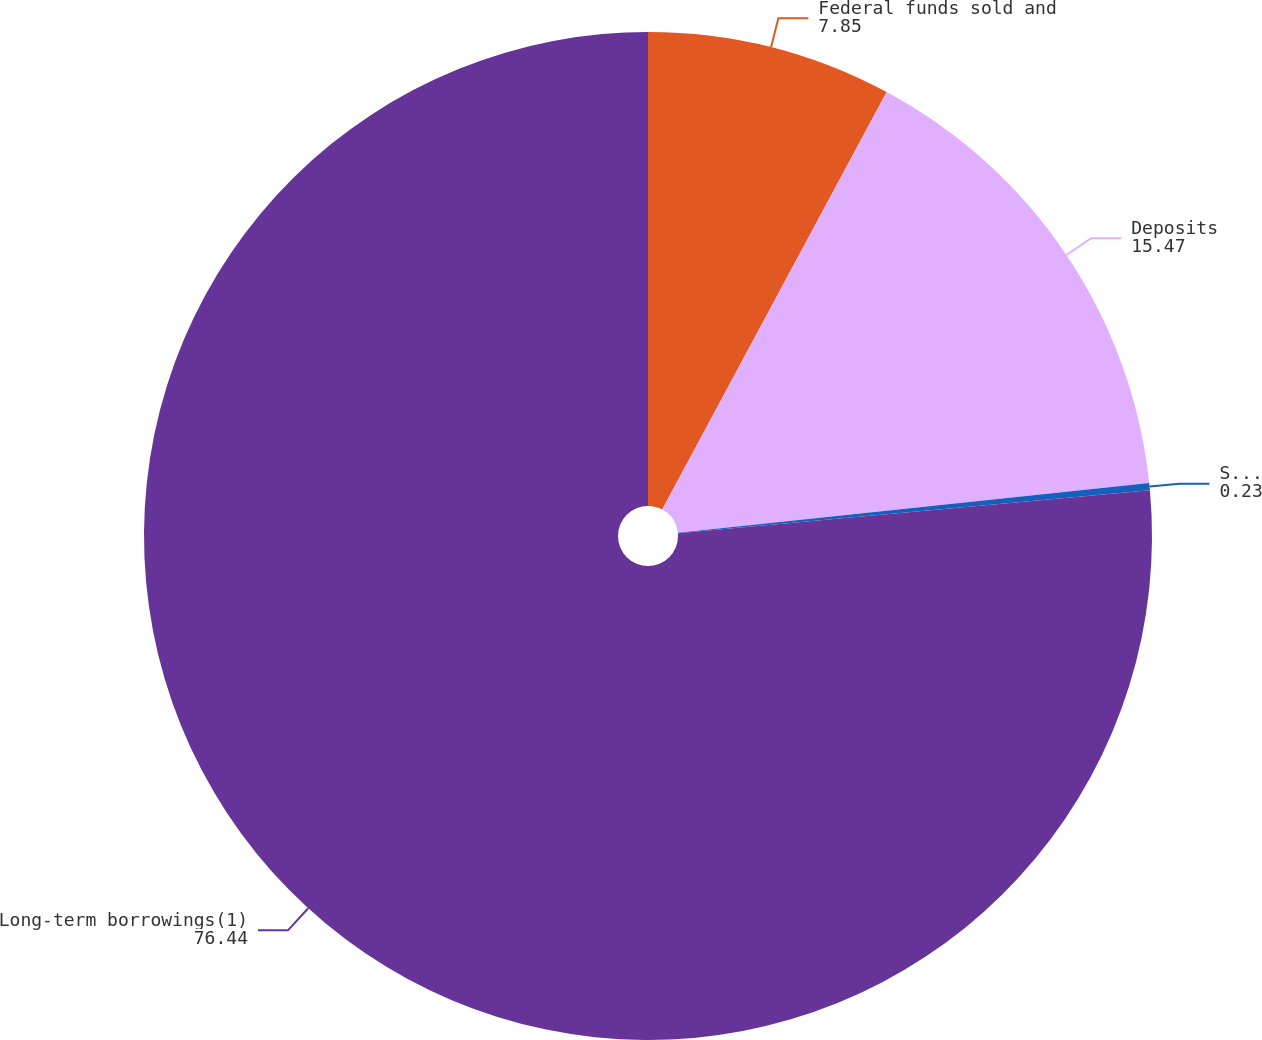Convert chart to OTSL. <chart><loc_0><loc_0><loc_500><loc_500><pie_chart><fcel>Federal funds sold and<fcel>Deposits<fcel>Securities sold under<fcel>Long-term borrowings(1)<nl><fcel>7.85%<fcel>15.47%<fcel>0.23%<fcel>76.44%<nl></chart> 